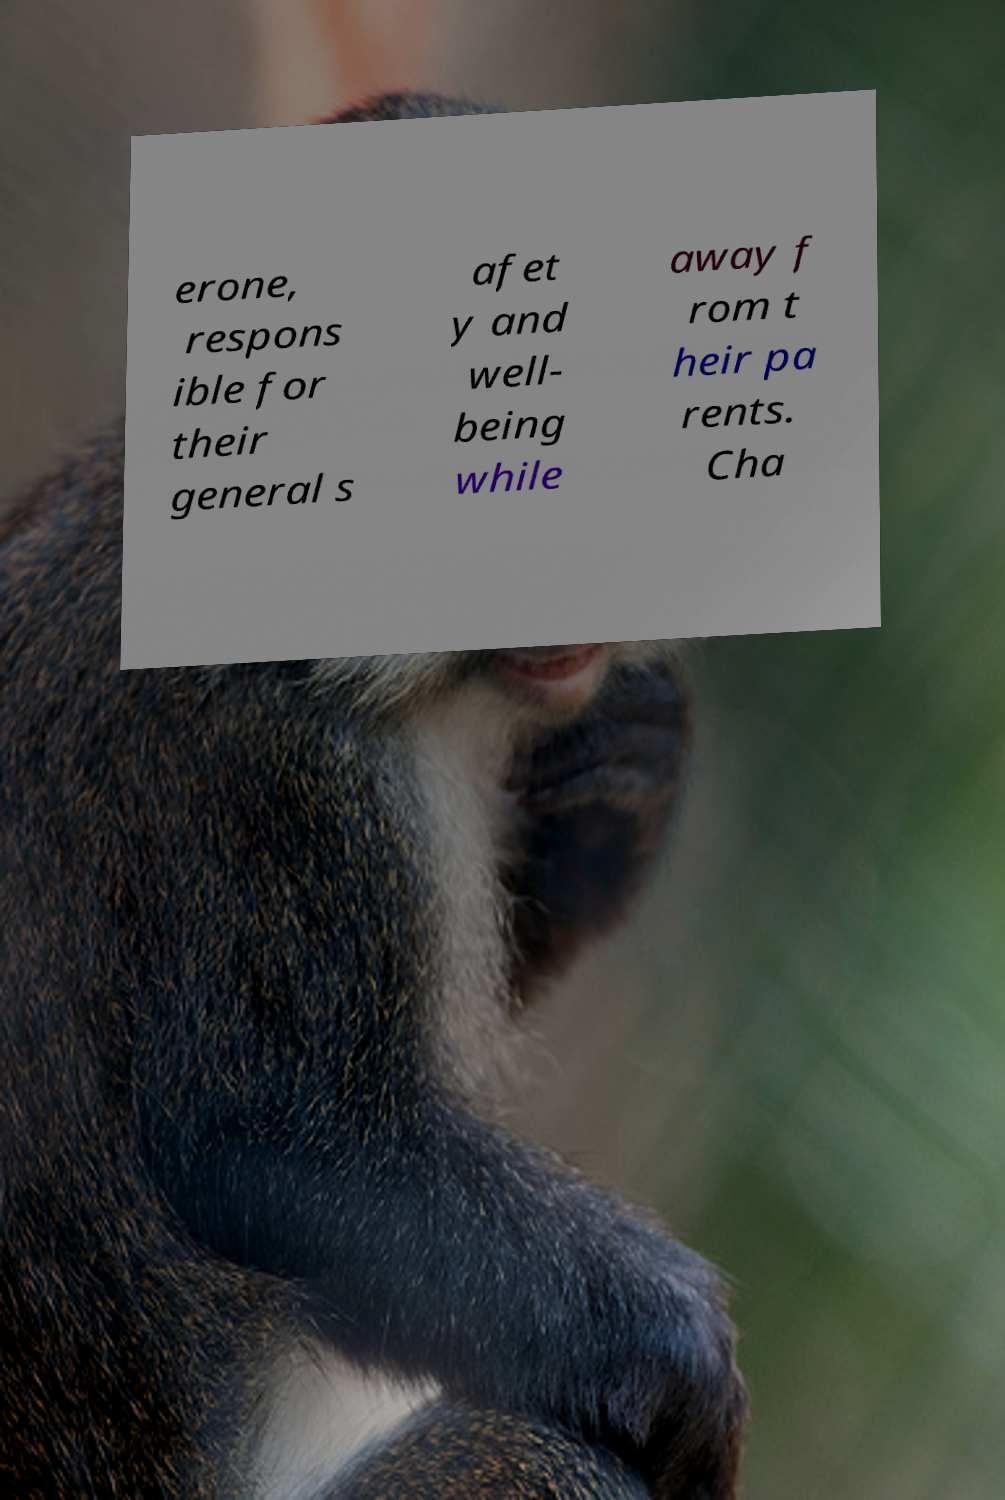For documentation purposes, I need the text within this image transcribed. Could you provide that? erone, respons ible for their general s afet y and well- being while away f rom t heir pa rents. Cha 